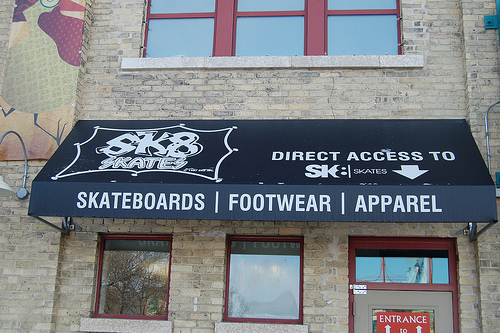<image>
Is the window above the door? Yes. The window is positioned above the door in the vertical space, higher up in the scene. 